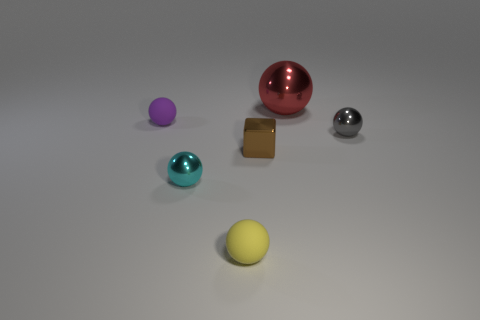The red shiny object has what size?
Offer a terse response. Large. How many brown things are big metallic spheres or tiny metallic blocks?
Keep it short and to the point. 1. What size is the metal sphere behind the ball that is on the right side of the red metal object?
Make the answer very short. Large. What number of other objects are there of the same material as the small cyan object?
Provide a short and direct response. 3. The small brown thing that is made of the same material as the small cyan sphere is what shape?
Make the answer very short. Cube. Is there any other thing that is the same color as the big metallic ball?
Offer a terse response. No. Is the number of tiny shiny objects that are left of the red shiny sphere greater than the number of red balls?
Your response must be concise. Yes. Is the shape of the tiny cyan thing the same as the small metal object behind the tiny brown metallic thing?
Your response must be concise. Yes. How many purple rubber things have the same size as the yellow matte thing?
Give a very brief answer. 1. There is a matte ball behind the rubber ball in front of the small block; what number of tiny balls are in front of it?
Provide a short and direct response. 3. 